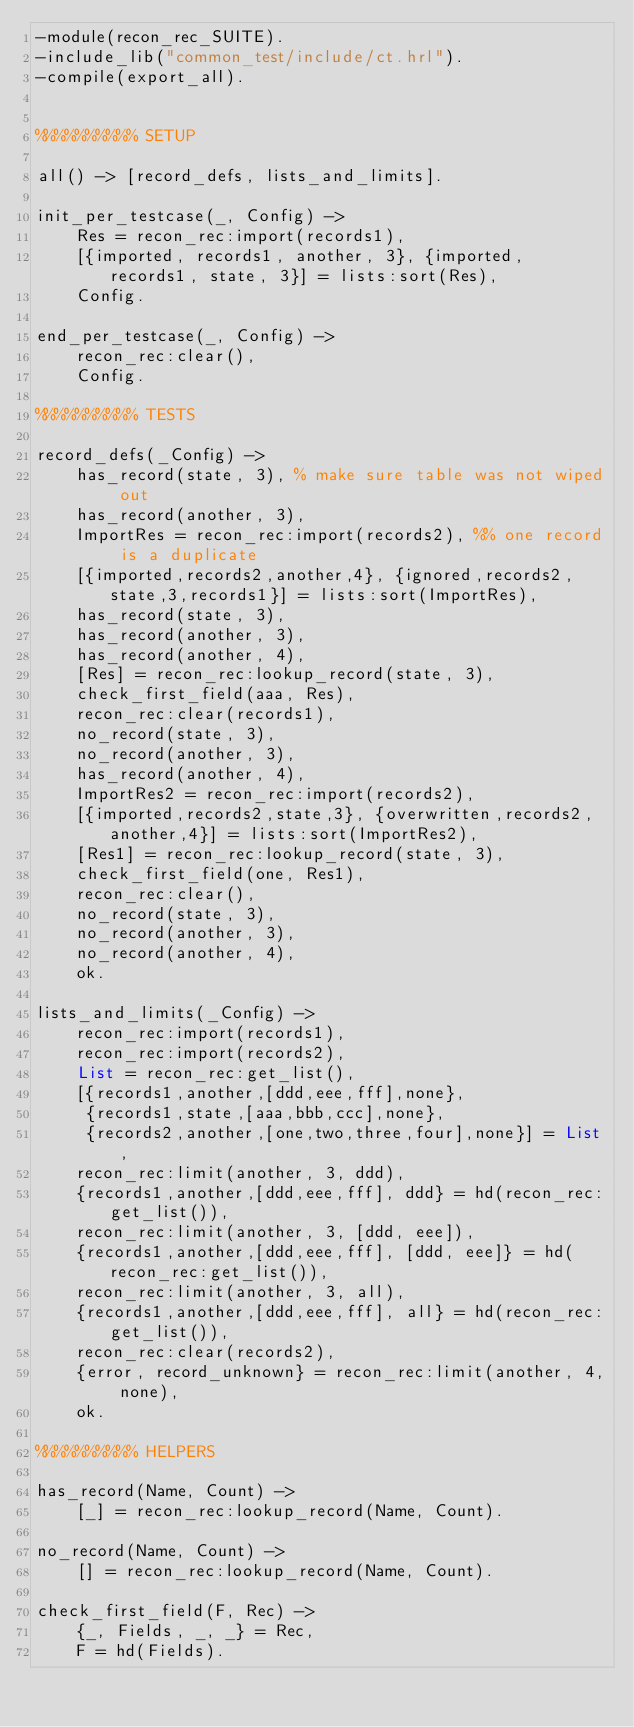Convert code to text. <code><loc_0><loc_0><loc_500><loc_500><_Erlang_>-module(recon_rec_SUITE).
-include_lib("common_test/include/ct.hrl").
-compile(export_all).


%%%%%%%%%% SETUP

all() -> [record_defs, lists_and_limits].

init_per_testcase(_, Config) ->
    Res = recon_rec:import(records1),
    [{imported, records1, another, 3}, {imported, records1, state, 3}] = lists:sort(Res),
    Config.

end_per_testcase(_, Config) ->
    recon_rec:clear(),
    Config.

%%%%%%%%%% TESTS

record_defs(_Config) ->
    has_record(state, 3), % make sure table was not wiped out
    has_record(another, 3),
    ImportRes = recon_rec:import(records2), %% one record is a duplicate
    [{imported,records2,another,4}, {ignored,records2,state,3,records1}] = lists:sort(ImportRes),
    has_record(state, 3),
    has_record(another, 3),
    has_record(another, 4),
    [Res] = recon_rec:lookup_record(state, 3),
    check_first_field(aaa, Res),
    recon_rec:clear(records1),
    no_record(state, 3),
    no_record(another, 3),
    has_record(another, 4),
    ImportRes2 = recon_rec:import(records2),
    [{imported,records2,state,3}, {overwritten,records2,another,4}] = lists:sort(ImportRes2),
    [Res1] = recon_rec:lookup_record(state, 3),
    check_first_field(one, Res1),
    recon_rec:clear(),
    no_record(state, 3),
    no_record(another, 3),
    no_record(another, 4),
    ok.

lists_and_limits(_Config) ->
    recon_rec:import(records1),
    recon_rec:import(records2),
    List = recon_rec:get_list(),
    [{records1,another,[ddd,eee,fff],none},
     {records1,state,[aaa,bbb,ccc],none},
     {records2,another,[one,two,three,four],none}] = List,
    recon_rec:limit(another, 3, ddd),
    {records1,another,[ddd,eee,fff], ddd} = hd(recon_rec:get_list()),
    recon_rec:limit(another, 3, [ddd, eee]),
    {records1,another,[ddd,eee,fff], [ddd, eee]} = hd(recon_rec:get_list()),
    recon_rec:limit(another, 3, all),
    {records1,another,[ddd,eee,fff], all} = hd(recon_rec:get_list()),
    recon_rec:clear(records2),
    {error, record_unknown} = recon_rec:limit(another, 4, none),
    ok.

%%%%%%%%%% HELPERS

has_record(Name, Count) ->
    [_] = recon_rec:lookup_record(Name, Count).

no_record(Name, Count) ->
    [] = recon_rec:lookup_record(Name, Count).

check_first_field(F, Rec) ->
    {_, Fields, _, _} = Rec,
    F = hd(Fields).
</code> 